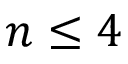Convert formula to latex. <formula><loc_0><loc_0><loc_500><loc_500>n \leq 4</formula> 